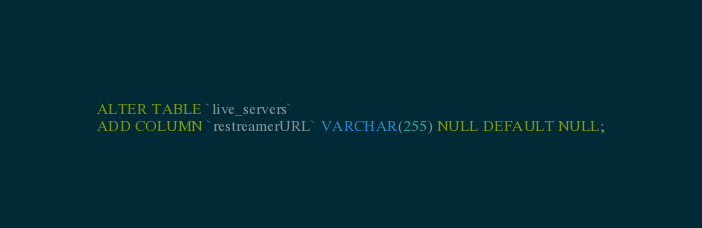Convert code to text. <code><loc_0><loc_0><loc_500><loc_500><_SQL_>ALTER TABLE `live_servers` 
ADD COLUMN `restreamerURL` VARCHAR(255) NULL DEFAULT NULL;</code> 